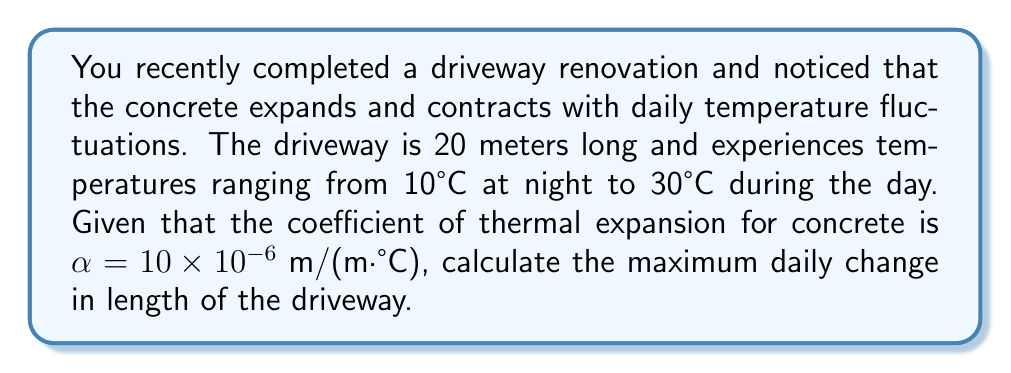Can you solve this math problem? To solve this problem, we'll use the thermal expansion formula:

$$\Delta L = \alpha L_0 \Delta T$$

Where:
$\Delta L$ = change in length
$\alpha$ = coefficient of thermal expansion
$L_0$ = initial length
$\Delta T$ = change in temperature

Step 1: Identify the given values
- Initial length, $L_0 = 20 \text{ m}$
- Coefficient of thermal expansion, $\alpha = 10 \times 10^{-6} \text{ m/(m·°C)}$
- Temperature range: 10°C to 30°C

Step 2: Calculate the temperature change
$\Delta T = 30°C - 10°C = 20°C$

Step 3: Apply the thermal expansion formula
$$\begin{align}
\Delta L &= \alpha L_0 \Delta T \\
&= (10 \times 10^{-6} \text{ m/(m·°C)}) \times (20 \text{ m}) \times (20°C) \\
&= 4 \times 10^{-3} \text{ m} \\
&= 4 \text{ mm}
\end{align}$$

Therefore, the maximum daily change in length of the driveway is 4 mm.
Answer: 4 mm 